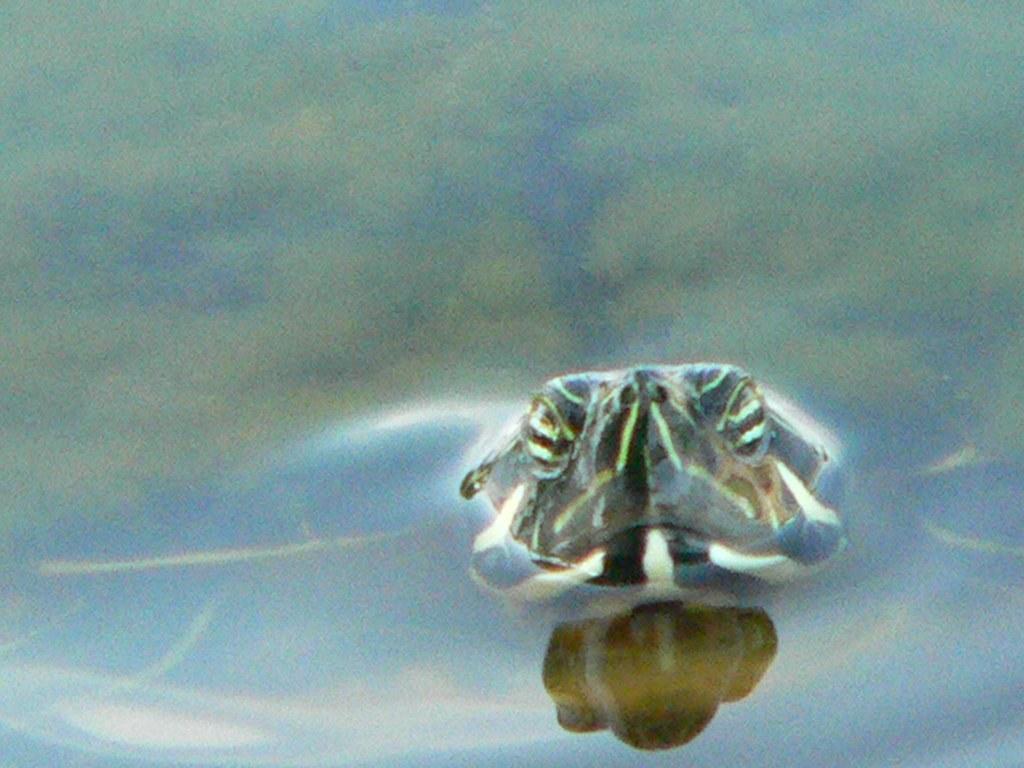Describe this image in one or two sentences. In this image I can see a mammal in the water. 